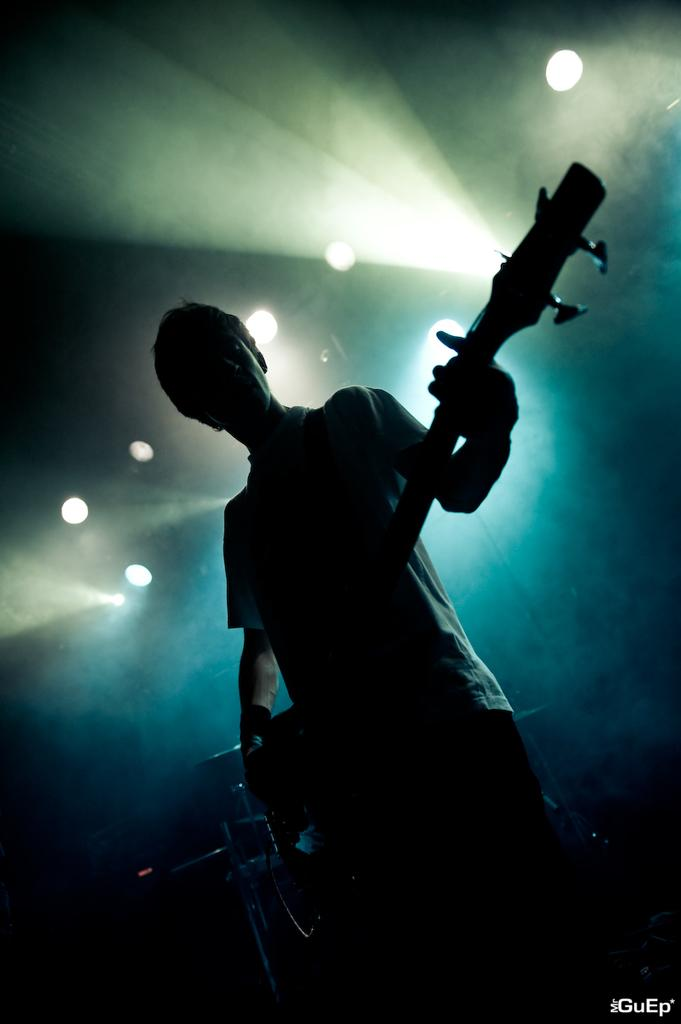What is the person in the image doing? The person is standing and holding a guitar. What other musical instrument can be seen in the image? There are drums visible in the image. What is present at the top of the image? There are lights at the top of the image. What is located at the bottom right of the image? There is text at the bottom right of the image. Where is the faucet located in the image? There is no faucet present in the image. What type of ear is visible on the person in the image? The person in the image does not have any visible ears; they are only holding a guitar. 